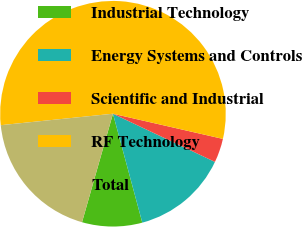<chart> <loc_0><loc_0><loc_500><loc_500><pie_chart><fcel>Industrial Technology<fcel>Energy Systems and Controls<fcel>Scientific and Industrial<fcel>RF Technology<fcel>Total<nl><fcel>8.61%<fcel>13.79%<fcel>3.44%<fcel>55.2%<fcel>18.96%<nl></chart> 